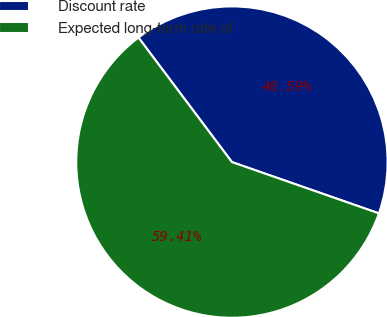Convert chart to OTSL. <chart><loc_0><loc_0><loc_500><loc_500><pie_chart><fcel>Discount rate<fcel>Expected long-term rate of<nl><fcel>40.59%<fcel>59.41%<nl></chart> 